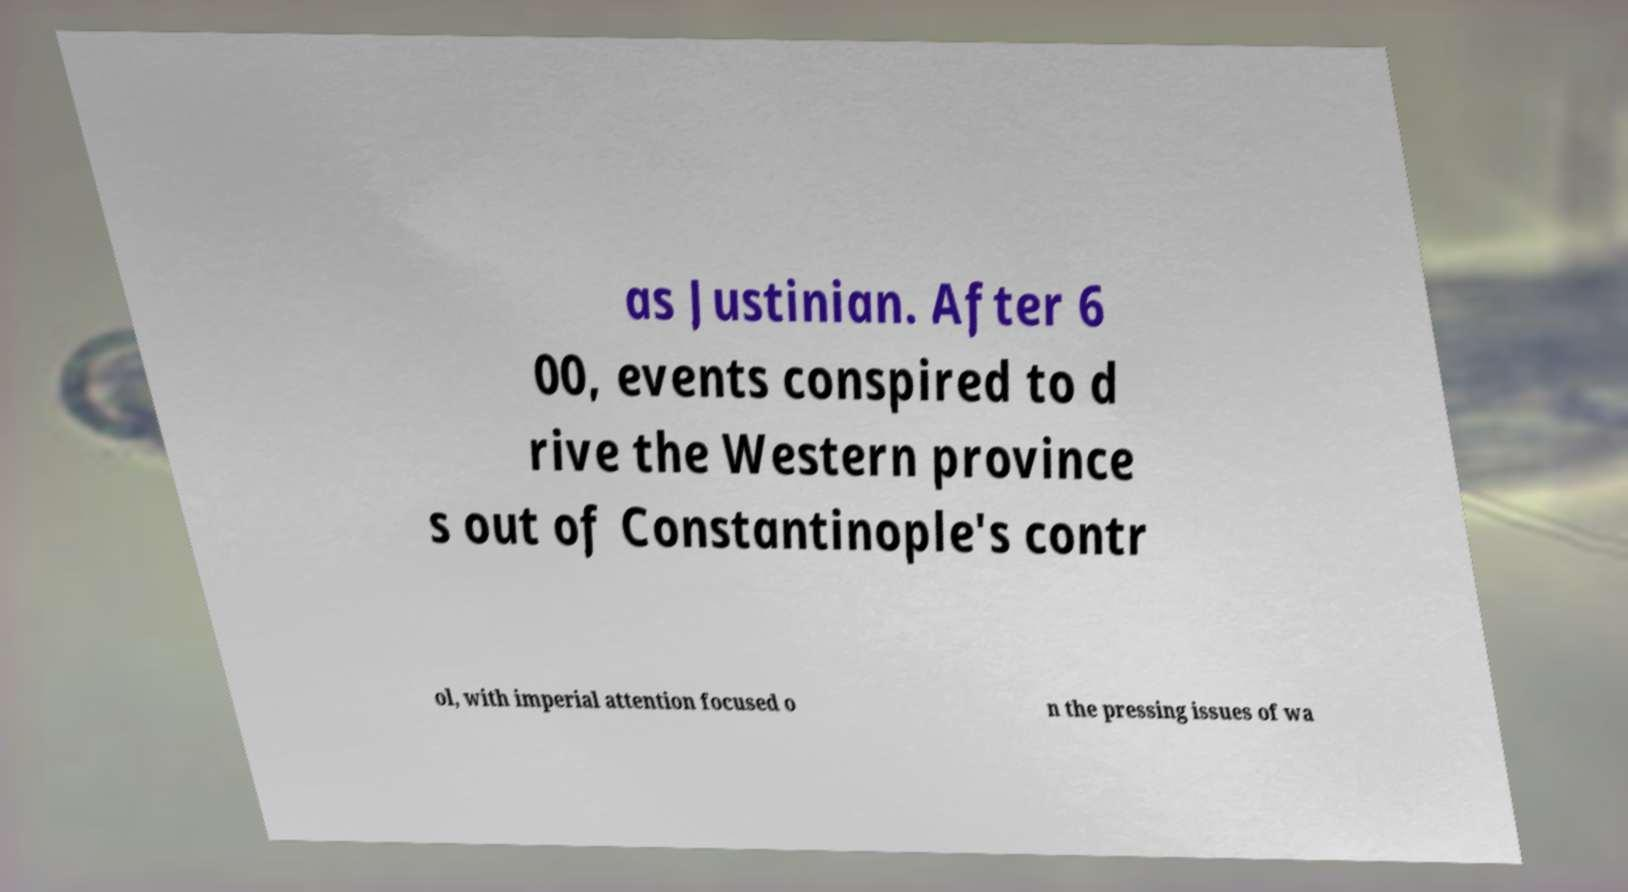Please read and relay the text visible in this image. What does it say? as Justinian. After 6 00, events conspired to d rive the Western province s out of Constantinople's contr ol, with imperial attention focused o n the pressing issues of wa 